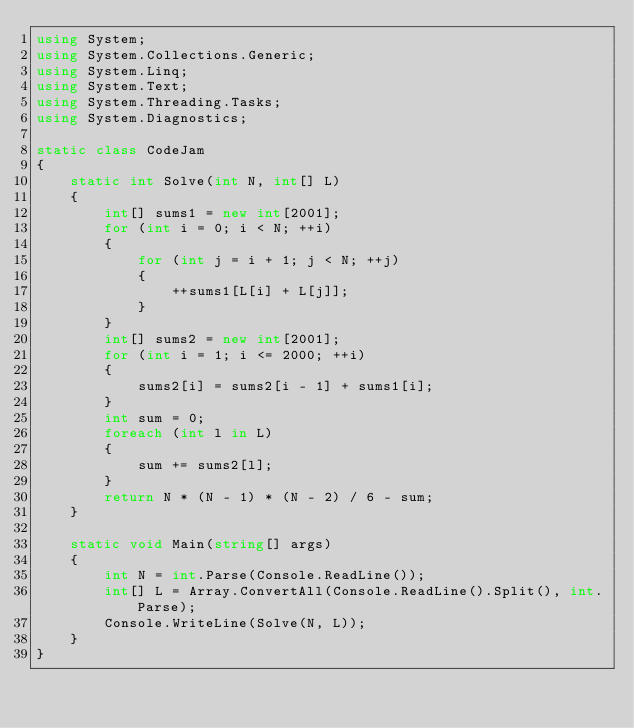Convert code to text. <code><loc_0><loc_0><loc_500><loc_500><_C#_>using System;
using System.Collections.Generic;
using System.Linq;
using System.Text;
using System.Threading.Tasks;
using System.Diagnostics;

static class CodeJam
{
    static int Solve(int N, int[] L)
    {
        int[] sums1 = new int[2001];
        for (int i = 0; i < N; ++i)
        {
            for (int j = i + 1; j < N; ++j)
            {
                ++sums1[L[i] + L[j]];
            }
        }
        int[] sums2 = new int[2001];
        for (int i = 1; i <= 2000; ++i)
        {
            sums2[i] = sums2[i - 1] + sums1[i];
        }
        int sum = 0;
        foreach (int l in L)
        {
            sum += sums2[l];
        }
        return N * (N - 1) * (N - 2) / 6 - sum;
    }

    static void Main(string[] args)
    {
        int N = int.Parse(Console.ReadLine());
        int[] L = Array.ConvertAll(Console.ReadLine().Split(), int.Parse);
        Console.WriteLine(Solve(N, L));
    }
}
</code> 